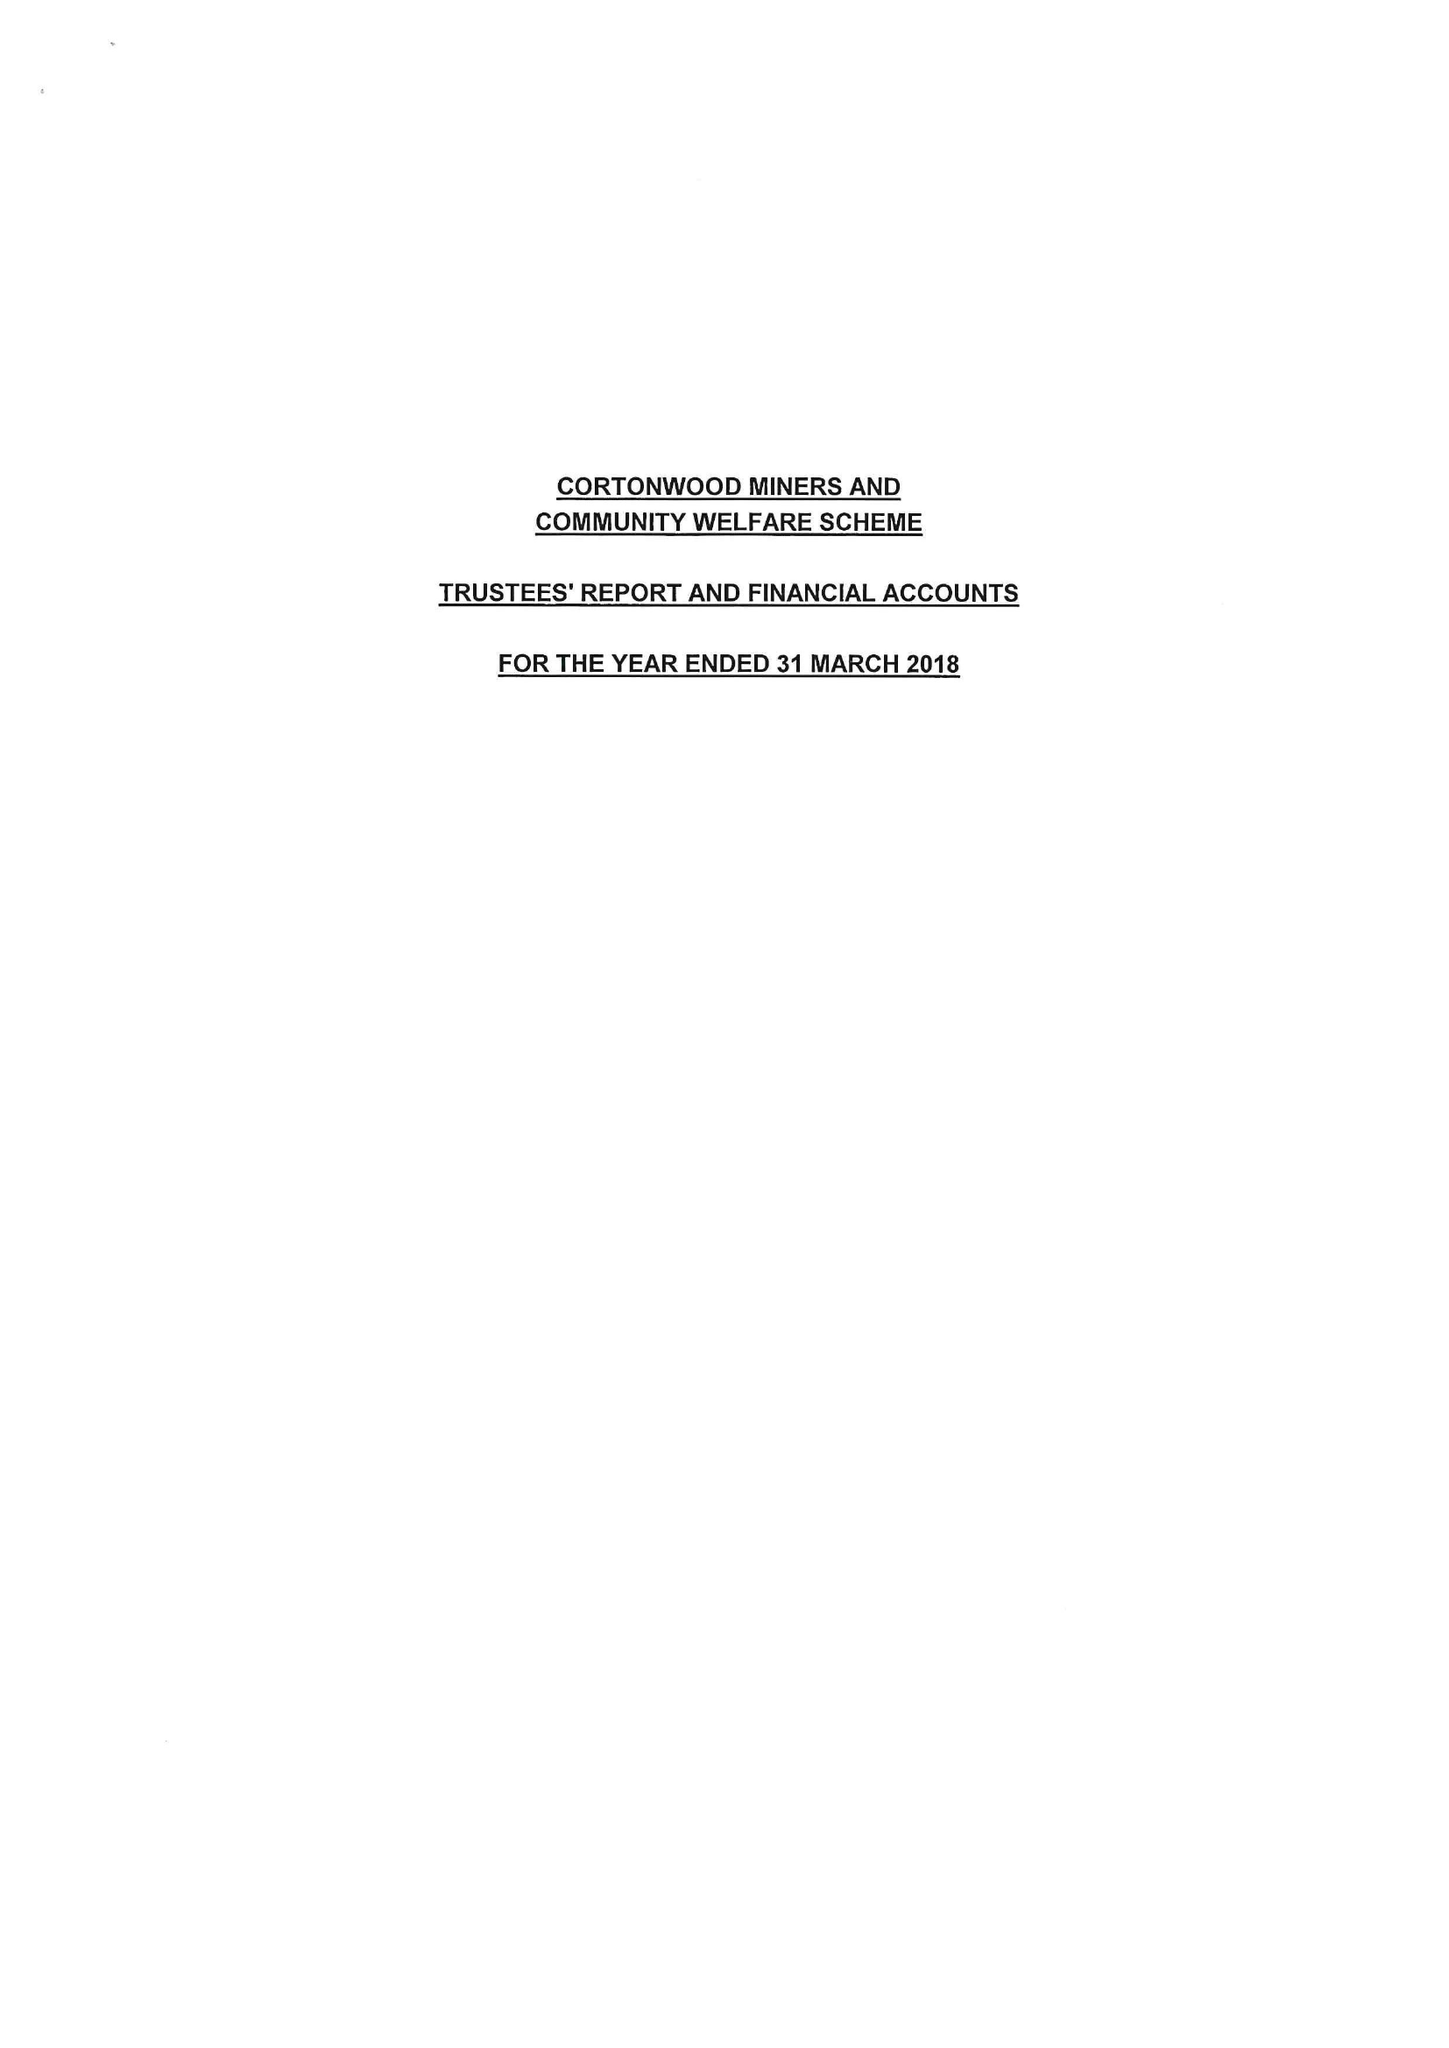What is the value for the address__post_town?
Answer the question using a single word or phrase. BARNSLEY 